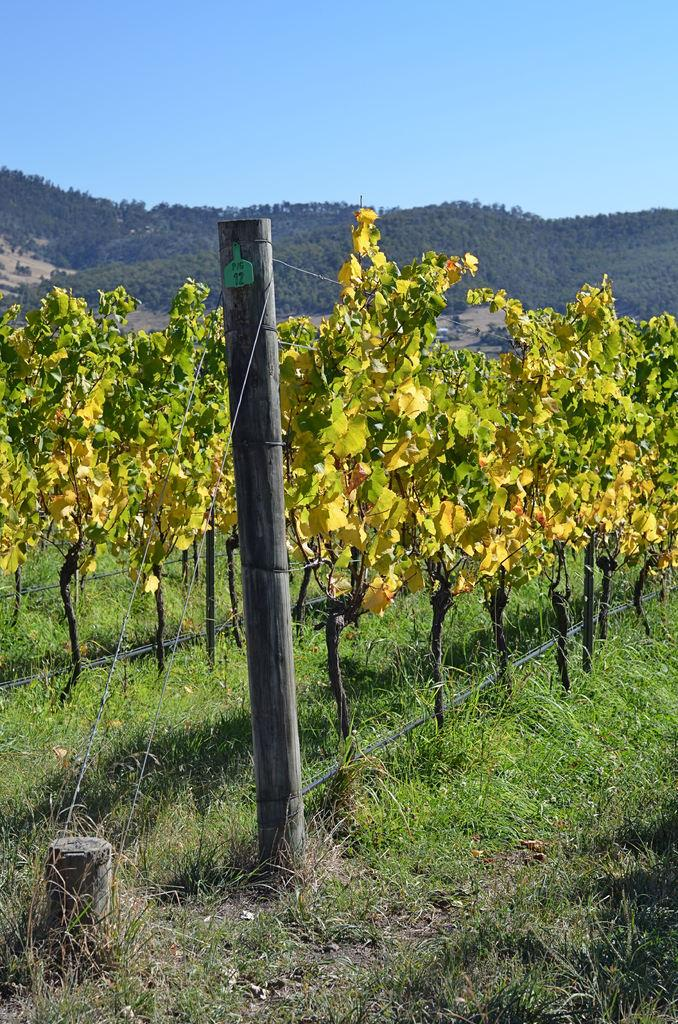What is the main object in the image? There is a wooden pole in the image. What can be seen near the wooden pole? There is fencing for plants in the image. What is visible in the background of the image? Hills, trees, and grass are visible in the background of the image. How many giants are playing on the team in the image? There are no giants or teams present in the image; it features a wooden pole and fencing for plants with a background of hills, trees, and grass. 